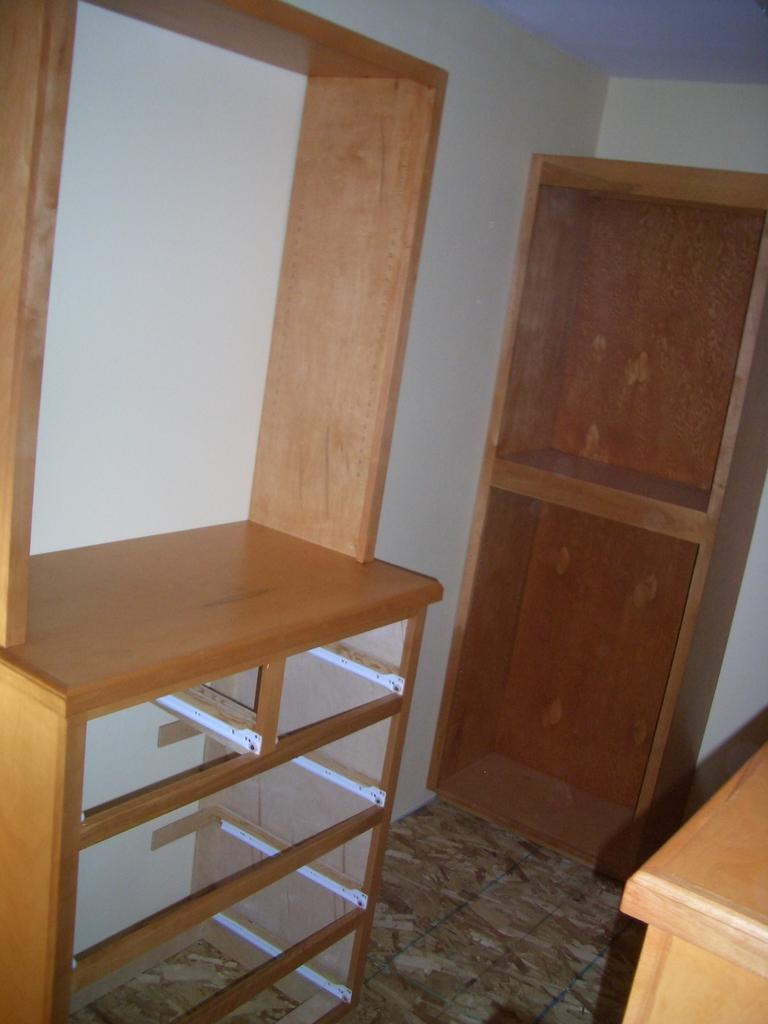What type of space is depicted in the image? The image is of a room. What type of furniture can be seen in the room? There are cupboards in the room. Can you describe the condition of the cupboards? The cupboards are incomplete. What type of game is being played in the room in the image? There is no game being played in the room in the image. Can you hear any thunder in the room in the image? There is no indication of thunder or any sound in the image, as it is a still image. Are there any police officers present in the room in the image? There is no mention or presence of police officers in the image. 